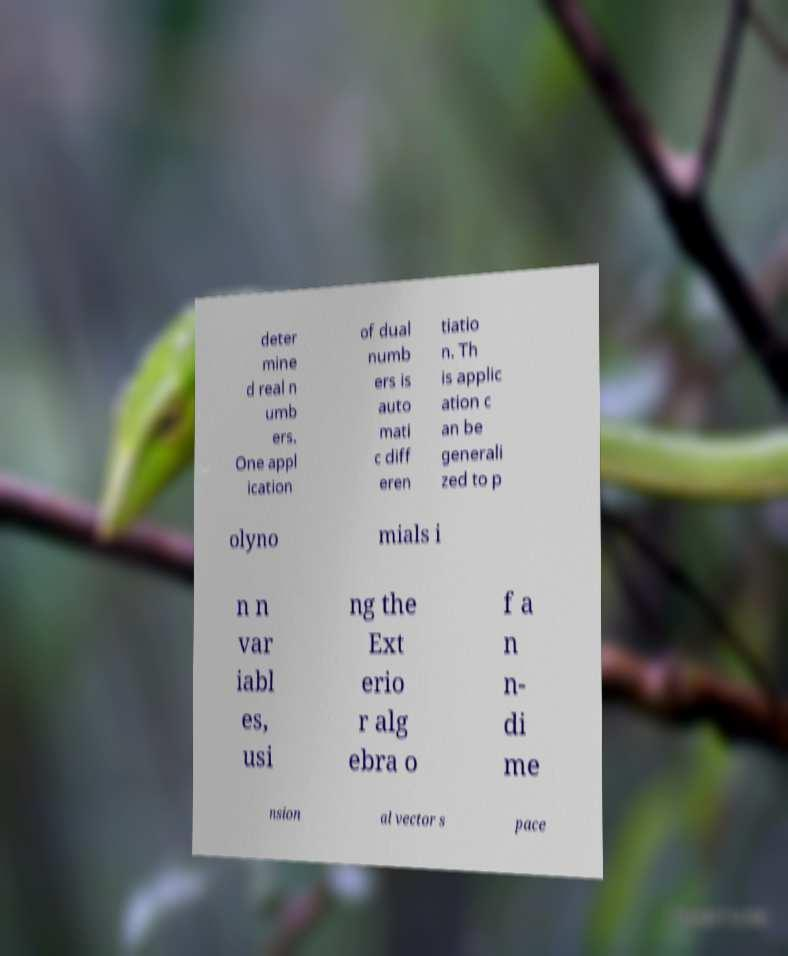There's text embedded in this image that I need extracted. Can you transcribe it verbatim? deter mine d real n umb ers. One appl ication of dual numb ers is auto mati c diff eren tiatio n. Th is applic ation c an be generali zed to p olyno mials i n n var iabl es, usi ng the Ext erio r alg ebra o f a n n- di me nsion al vector s pace 